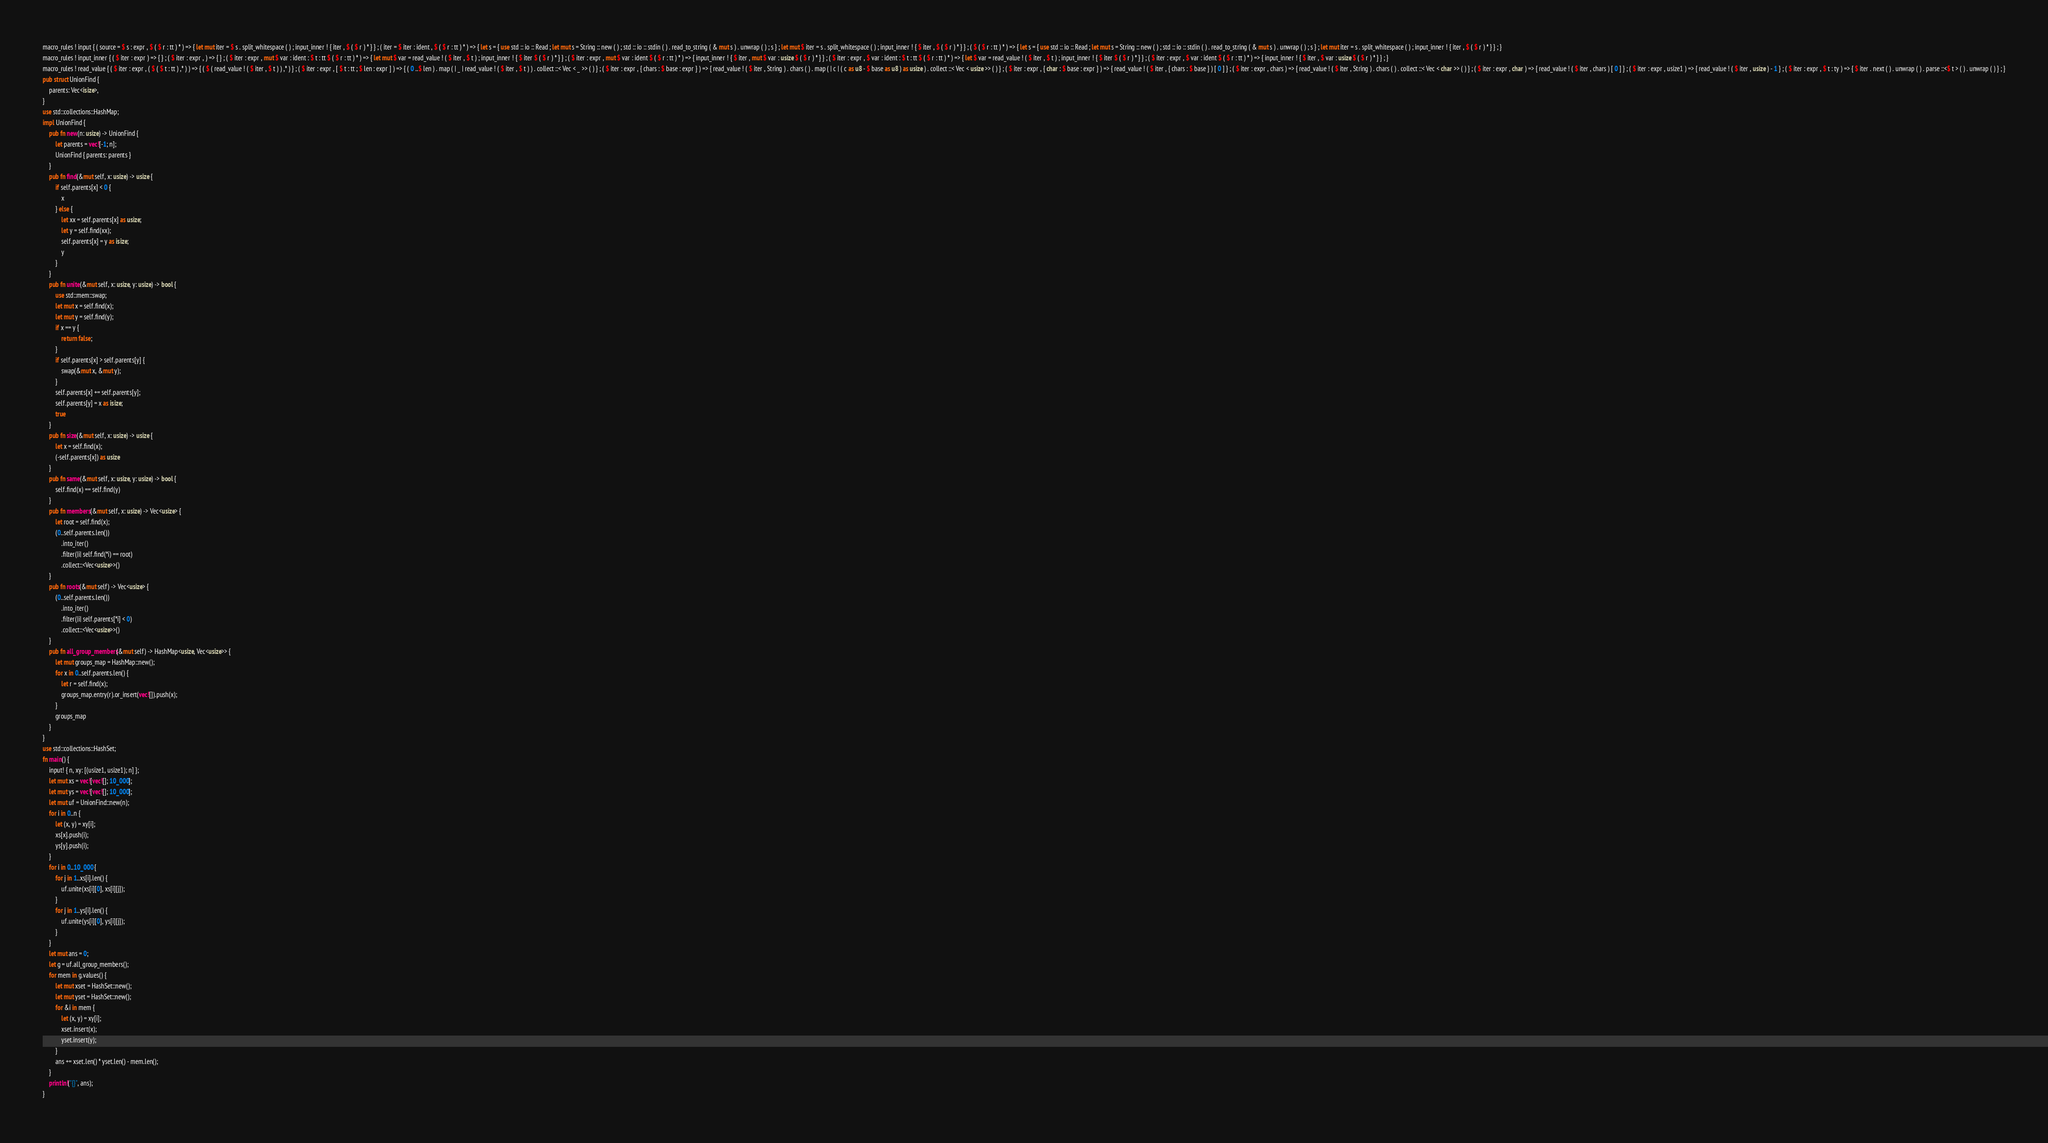<code> <loc_0><loc_0><loc_500><loc_500><_Rust_>macro_rules ! input { ( source = $ s : expr , $ ( $ r : tt ) * ) => { let mut iter = $ s . split_whitespace ( ) ; input_inner ! { iter , $ ( $ r ) * } } ; ( iter = $ iter : ident , $ ( $ r : tt ) * ) => { let s = { use std :: io :: Read ; let mut s = String :: new ( ) ; std :: io :: stdin ( ) . read_to_string ( & mut s ) . unwrap ( ) ; s } ; let mut $ iter = s . split_whitespace ( ) ; input_inner ! { $ iter , $ ( $ r ) * } } ; ( $ ( $ r : tt ) * ) => { let s = { use std :: io :: Read ; let mut s = String :: new ( ) ; std :: io :: stdin ( ) . read_to_string ( & mut s ) . unwrap ( ) ; s } ; let mut iter = s . split_whitespace ( ) ; input_inner ! { iter , $ ( $ r ) * } } ; }
macro_rules ! input_inner { ( $ iter : expr ) => { } ; ( $ iter : expr , ) => { } ; ( $ iter : expr , mut $ var : ident : $ t : tt $ ( $ r : tt ) * ) => { let mut $ var = read_value ! ( $ iter , $ t ) ; input_inner ! { $ iter $ ( $ r ) * } } ; ( $ iter : expr , mut $ var : ident $ ( $ r : tt ) * ) => { input_inner ! { $ iter , mut $ var : usize $ ( $ r ) * } } ; ( $ iter : expr , $ var : ident : $ t : tt $ ( $ r : tt ) * ) => { let $ var = read_value ! ( $ iter , $ t ) ; input_inner ! { $ iter $ ( $ r ) * } } ; ( $ iter : expr , $ var : ident $ ( $ r : tt ) * ) => { input_inner ! { $ iter , $ var : usize $ ( $ r ) * } } ; }
macro_rules ! read_value { ( $ iter : expr , ( $ ( $ t : tt ) ,* ) ) => { ( $ ( read_value ! ( $ iter , $ t ) ) ,* ) } ; ( $ iter : expr , [ $ t : tt ; $ len : expr ] ) => { ( 0 ..$ len ) . map ( | _ | read_value ! ( $ iter , $ t ) ) . collect ::< Vec < _ >> ( ) } ; ( $ iter : expr , { chars : $ base : expr } ) => { read_value ! ( $ iter , String ) . chars ( ) . map ( | c | ( c as u8 - $ base as u8 ) as usize ) . collect ::< Vec < usize >> ( ) } ; ( $ iter : expr , { char : $ base : expr } ) => { read_value ! ( $ iter , { chars : $ base } ) [ 0 ] } ; ( $ iter : expr , chars ) => { read_value ! ( $ iter , String ) . chars ( ) . collect ::< Vec < char >> ( ) } ; ( $ iter : expr , char ) => { read_value ! ( $ iter , chars ) [ 0 ] } ; ( $ iter : expr , usize1 ) => { read_value ! ( $ iter , usize ) - 1 } ; ( $ iter : expr , $ t : ty ) => { $ iter . next ( ) . unwrap ( ) . parse ::<$ t > ( ) . unwrap ( ) } ; }
pub struct UnionFind {
    parents: Vec<isize>,
}
use std::collections::HashMap;
impl UnionFind {
    pub fn new(n: usize) -> UnionFind {
        let parents = vec![-1; n];
        UnionFind { parents: parents }
    }
    pub fn find(&mut self, x: usize) -> usize {
        if self.parents[x] < 0 {
            x
        } else {
            let xx = self.parents[x] as usize;
            let y = self.find(xx);
            self.parents[x] = y as isize;
            y
        }
    }
    pub fn unite(&mut self, x: usize, y: usize) -> bool {
        use std::mem::swap;
        let mut x = self.find(x);
        let mut y = self.find(y);
        if x == y {
            return false;
        }
        if self.parents[x] > self.parents[y] {
            swap(&mut x, &mut y);
        }
        self.parents[x] += self.parents[y];
        self.parents[y] = x as isize;
        true
    }
    pub fn size(&mut self, x: usize) -> usize {
        let x = self.find(x);
        (-self.parents[x]) as usize
    }
    pub fn same(&mut self, x: usize, y: usize) -> bool {
        self.find(x) == self.find(y)
    }
    pub fn members(&mut self, x: usize) -> Vec<usize> {
        let root = self.find(x);
        (0..self.parents.len())
            .into_iter()
            .filter(|i| self.find(*i) == root)
            .collect::<Vec<usize>>()
    }
    pub fn roots(&mut self) -> Vec<usize> {
        (0..self.parents.len())
            .into_iter()
            .filter(|i| self.parents[*i] < 0)
            .collect::<Vec<usize>>()
    }
    pub fn all_group_members(&mut self) -> HashMap<usize, Vec<usize>> {
        let mut groups_map = HashMap::new();
        for x in 0..self.parents.len() {
            let r = self.find(x);
            groups_map.entry(r).or_insert(vec![]).push(x);
        }
        groups_map
    }
}
use std::collections::HashSet;
fn main() {
    input! { n, xy: [(usize1, usize1); n] };
    let mut xs = vec![vec![]; 10_000];
    let mut ys = vec![vec![]; 10_000];
    let mut uf = UnionFind::new(n);
    for i in 0..n {
        let (x, y) = xy[i];
        xs[x].push(i);
        ys[y].push(i);
    }
    for i in 0..10_000 {
        for j in 1..xs[i].len() {
            uf.unite(xs[i][0], xs[i][j]);
        }
        for j in 1..ys[i].len() {
            uf.unite(ys[i][0], ys[i][j]);
        }
    }
    let mut ans = 0;
    let g = uf.all_group_members();
    for mem in g.values() {
        let mut xset = HashSet::new();
        let mut yset = HashSet::new();
        for &i in mem {
            let (x, y) = xy[i];
            xset.insert(x);
            yset.insert(y);
        }
        ans += xset.len() * yset.len() - mem.len();
    }
    println!("{}", ans);
}
</code> 